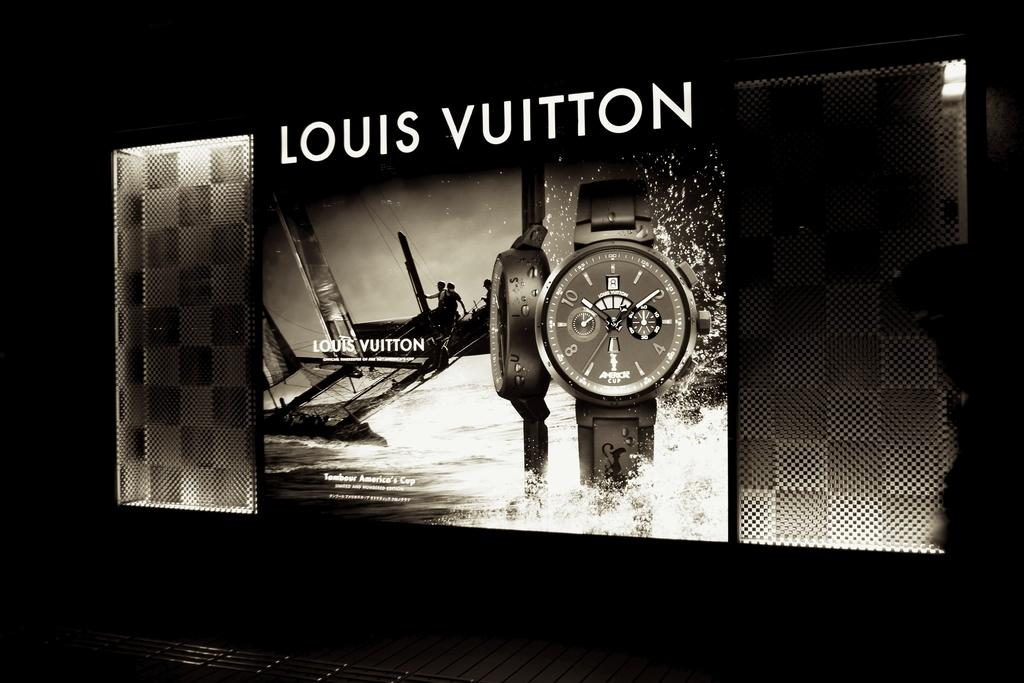<image>
Relay a brief, clear account of the picture shown. A lit up Louis Vuitton billboard features a watch. 